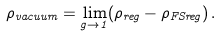<formula> <loc_0><loc_0><loc_500><loc_500>\rho _ { v a c u u m } = \lim _ { g \rightarrow 1 } ( \rho _ { r e g } - \rho _ { F S r e g } ) \, .</formula> 